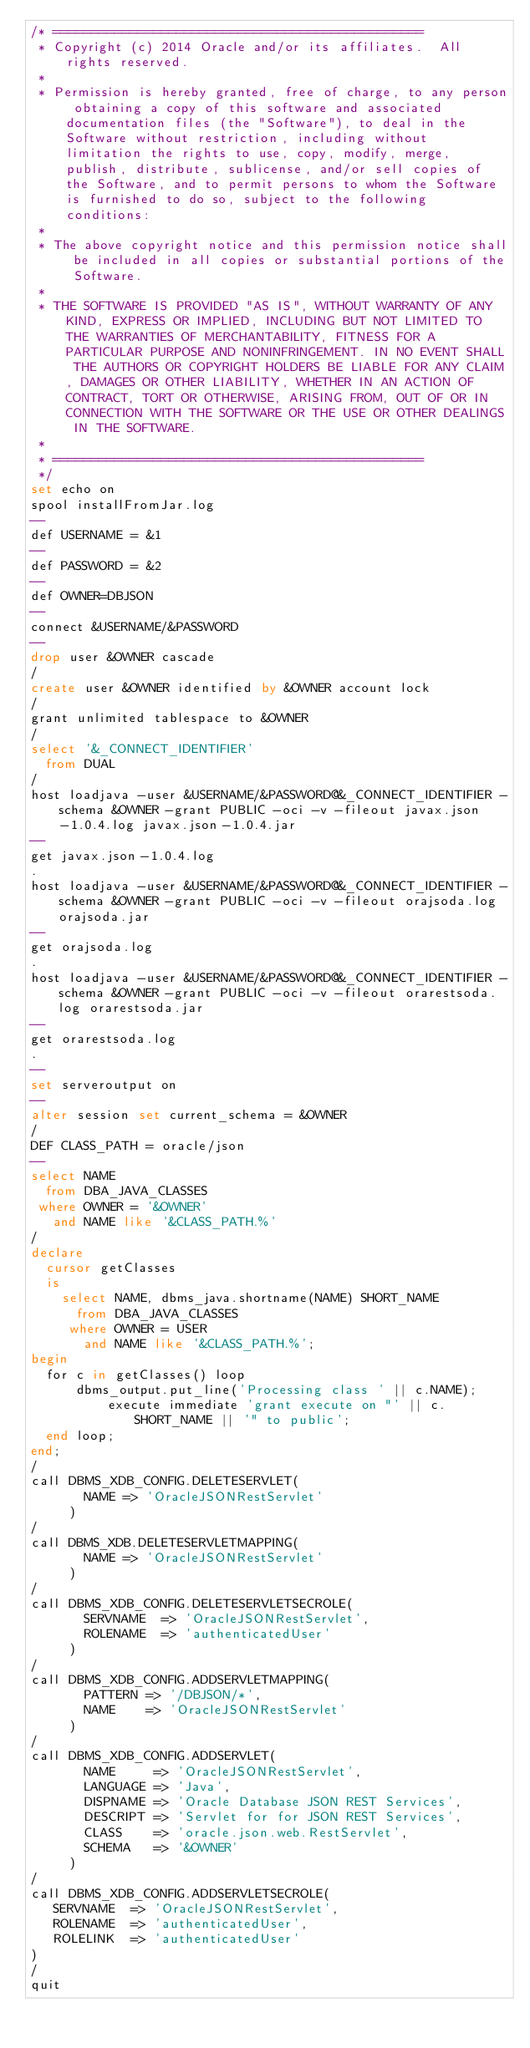<code> <loc_0><loc_0><loc_500><loc_500><_SQL_>/* ================================================  
 * Copyright (c) 2014 Oracle and/or its affiliates.  All rights reserved.
 *
 * Permission is hereby granted, free of charge, to any person obtaining a copy of this software and associated documentation files (the "Software"), to deal in the Software without restriction, including without limitation the rights to use, copy, modify, merge, publish, distribute, sublicense, and/or sell copies of the Software, and to permit persons to whom the Software is furnished to do so, subject to the following conditions:
 *
 * The above copyright notice and this permission notice shall be included in all copies or substantial portions of the Software.
 *
 * THE SOFTWARE IS PROVIDED "AS IS", WITHOUT WARRANTY OF ANY KIND, EXPRESS OR IMPLIED, INCLUDING BUT NOT LIMITED TO THE WARRANTIES OF MERCHANTABILITY, FITNESS FOR A PARTICULAR PURPOSE AND NONINFRINGEMENT. IN NO EVENT SHALL THE AUTHORS OR COPYRIGHT HOLDERS BE LIABLE FOR ANY CLAIM, DAMAGES OR OTHER LIABILITY, WHETHER IN AN ACTION OF CONTRACT, TORT OR OTHERWISE, ARISING FROM, OUT OF OR IN CONNECTION WITH THE SOFTWARE OR THE USE OR OTHER DEALINGS IN THE SOFTWARE.
 *
 * ================================================
 */
set echo on
spool installFromJar.log
--
def USERNAME = &1
--
def PASSWORD = &2
--
def OWNER=DBJSON
--
connect &USERNAME/&PASSWORD
--
drop user &OWNER cascade
/
create user &OWNER identified by &OWNER account lock
/
grant unlimited tablespace to &OWNER
/
select '&_CONNECT_IDENTIFIER'
  from DUAL
/
host loadjava -user &USERNAME/&PASSWORD@&_CONNECT_IDENTIFIER -schema &OWNER -grant PUBLIC -oci -v -fileout javax.json-1.0.4.log javax.json-1.0.4.jar 
--
get javax.json-1.0.4.log
.
host loadjava -user &USERNAME/&PASSWORD@&_CONNECT_IDENTIFIER -schema &OWNER -grant PUBLIC -oci -v -fileout orajsoda.log orajsoda.jar
--
get orajsoda.log
.
host loadjava -user &USERNAME/&PASSWORD@&_CONNECT_IDENTIFIER -schema &OWNER -grant PUBLIC -oci -v -fileout orarestsoda.log orarestsoda.jar 
--
get orarestsoda.log
.
--
set serveroutput on
--
alter session set current_schema = &OWNER
/
DEF CLASS_PATH = oracle/json
--
select NAME
  from DBA_JAVA_CLASSES
 where OWNER = '&OWNER'
   and NAME like '&CLASS_PATH.%'
/
declare 
  cursor getClasses 
  is
	select NAME, dbms_java.shortname(NAME) SHORT_NAME
	  from DBA_JAVA_CLASSES
	 where OWNER = USER
	   and NAME like '&CLASS_PATH.%';
begin
  for c in getClasses() loop
	  dbms_output.put_line('Processing class ' || c.NAME);
          execute immediate 'grant execute on "' || c.SHORT_NAME || '" to public';
  end loop;
end;
/
call DBMS_XDB_CONFIG.DELETESERVLET(
       NAME => 'OracleJSONRestServlet'
     )
/
call DBMS_XDB.DELETESERVLETMAPPING(
       NAME => 'OracleJSONRestServlet'
     )
/
call DBMS_XDB_CONFIG.DELETESERVLETSECROLE(
       SERVNAME  => 'OracleJSONRestServlet', 
       ROLENAME  => 'authenticatedUser'
     ) 
/    
call DBMS_XDB_CONFIG.ADDSERVLETMAPPING(
       PATTERN => '/DBJSON/*', 
       NAME    => 'OracleJSONRestServlet'
     )
/
call DBMS_XDB_CONFIG.ADDSERVLET(
       NAME     => 'OracleJSONRestServlet',
       LANGUAGE => 'Java',
       DISPNAME => 'Oracle Database JSON REST Services',
       DESCRIPT => 'Servlet for for JSON REST Services',
       CLASS    => 'oracle.json.web.RestServlet',
       SCHEMA   => '&OWNER'
     )
/
call DBMS_XDB_CONFIG.ADDSERVLETSECROLE(
   SERVNAME  => 'OracleJSONRestServlet',               
   ROLENAME  => 'authenticatedUser',
   ROLELINK  => 'authenticatedUser'
)     
/
quit
</code> 